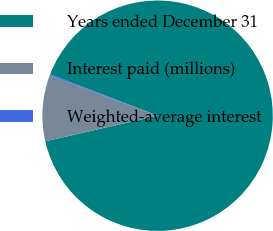Convert chart to OTSL. <chart><loc_0><loc_0><loc_500><loc_500><pie_chart><fcel>Years ended December 31<fcel>Interest paid (millions)<fcel>Weighted-average interest<nl><fcel>90.57%<fcel>9.24%<fcel>0.2%<nl></chart> 